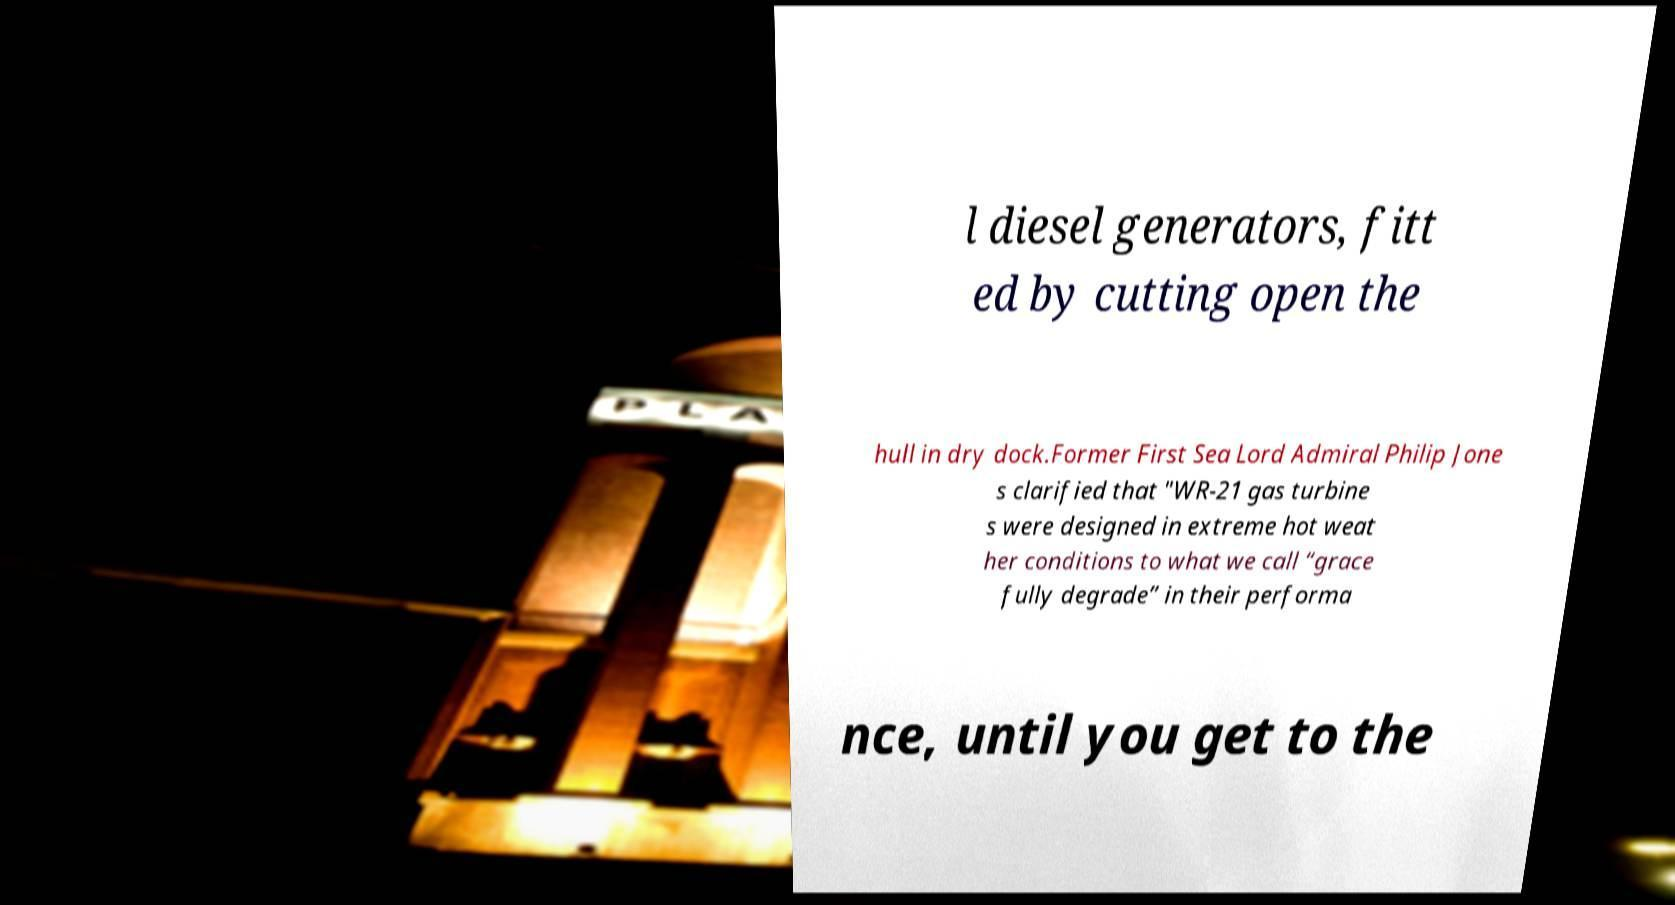I need the written content from this picture converted into text. Can you do that? l diesel generators, fitt ed by cutting open the hull in dry dock.Former First Sea Lord Admiral Philip Jone s clarified that "WR-21 gas turbine s were designed in extreme hot weat her conditions to what we call “grace fully degrade” in their performa nce, until you get to the 